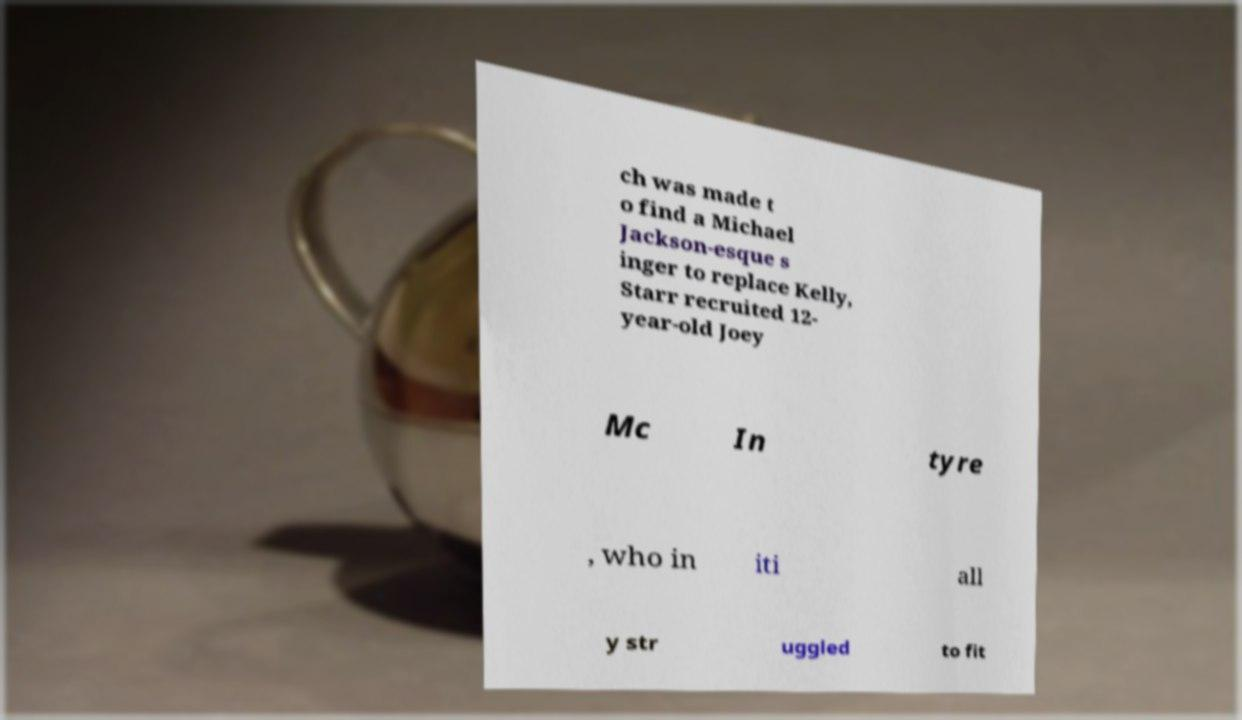Can you accurately transcribe the text from the provided image for me? ch was made t o find a Michael Jackson-esque s inger to replace Kelly, Starr recruited 12- year-old Joey Mc In tyre , who in iti all y str uggled to fit 